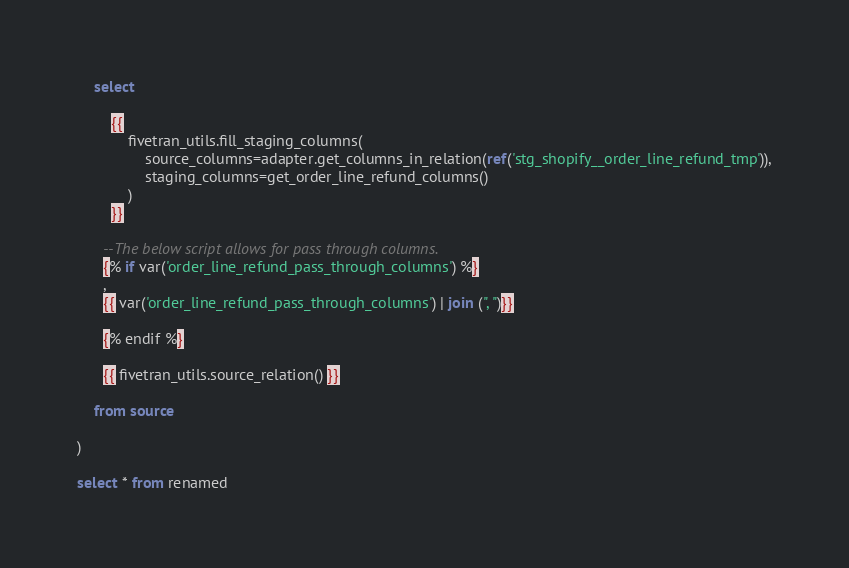Convert code to text. <code><loc_0><loc_0><loc_500><loc_500><_SQL_>    select
    
        {{
            fivetran_utils.fill_staging_columns(
                source_columns=adapter.get_columns_in_relation(ref('stg_shopify__order_line_refund_tmp')),
                staging_columns=get_order_line_refund_columns()
            )
        }}

      --The below script allows for pass through columns.
      {% if var('order_line_refund_pass_through_columns') %}
      ,
      {{ var('order_line_refund_pass_through_columns') | join (", ")}}

      {% endif %}

      {{ fivetran_utils.source_relation() }}

    from source

)

select * from renamed

</code> 